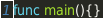<code> <loc_0><loc_0><loc_500><loc_500><_Go_>func main(){}
</code> 